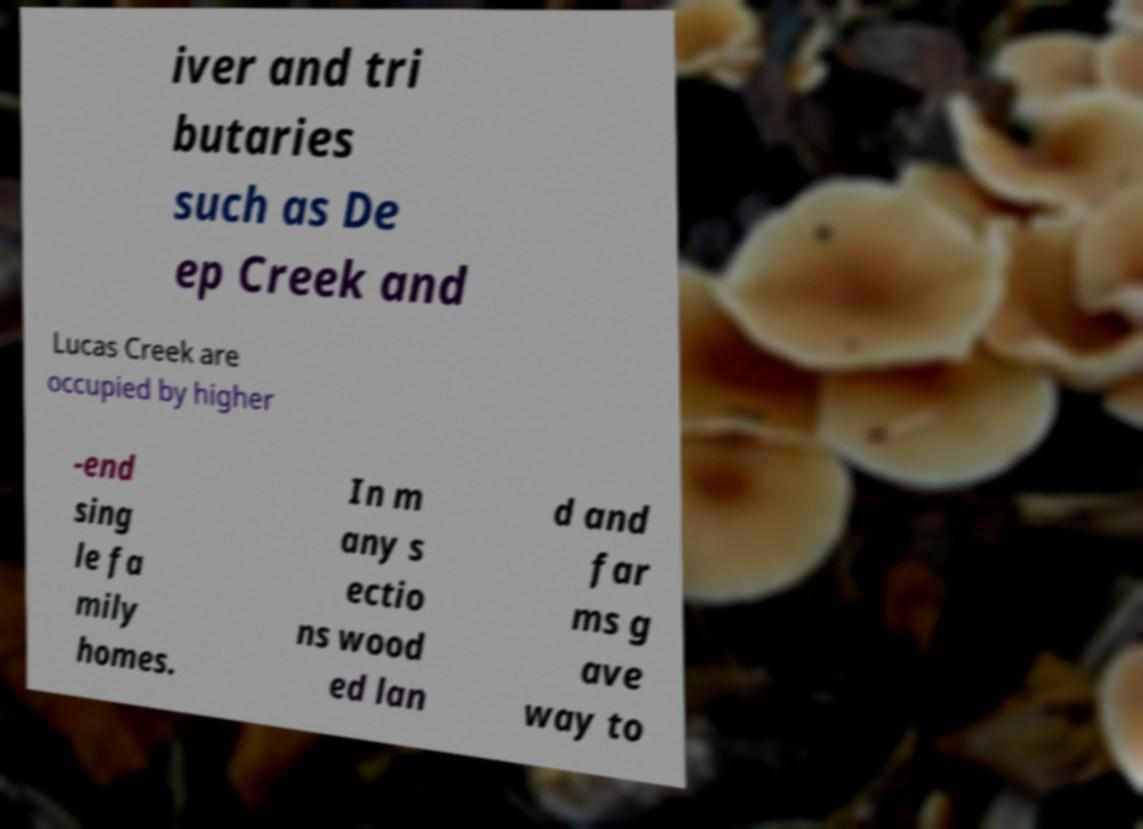Could you extract and type out the text from this image? iver and tri butaries such as De ep Creek and Lucas Creek are occupied by higher -end sing le fa mily homes. In m any s ectio ns wood ed lan d and far ms g ave way to 